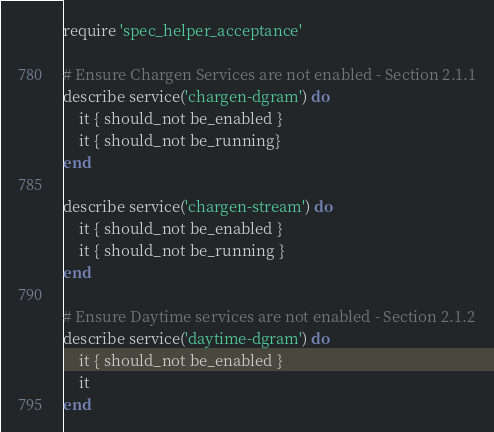<code> <loc_0><loc_0><loc_500><loc_500><_Ruby_>require 'spec_helper_acceptance'

# Ensure Chargen Services are not enabled - Section 2.1.1
describe service('chargen-dgram') do
    it { should_not be_enabled }
    it { should_not be_running}
end

describe service('chargen-stream') do
    it { should_not be_enabled }
    it { should_not be_running }
end

# Ensure Daytime services are not enabled - Section 2.1.2
describe service('daytime-dgram') do
    it { should_not be_enabled }
    it 
end</code> 